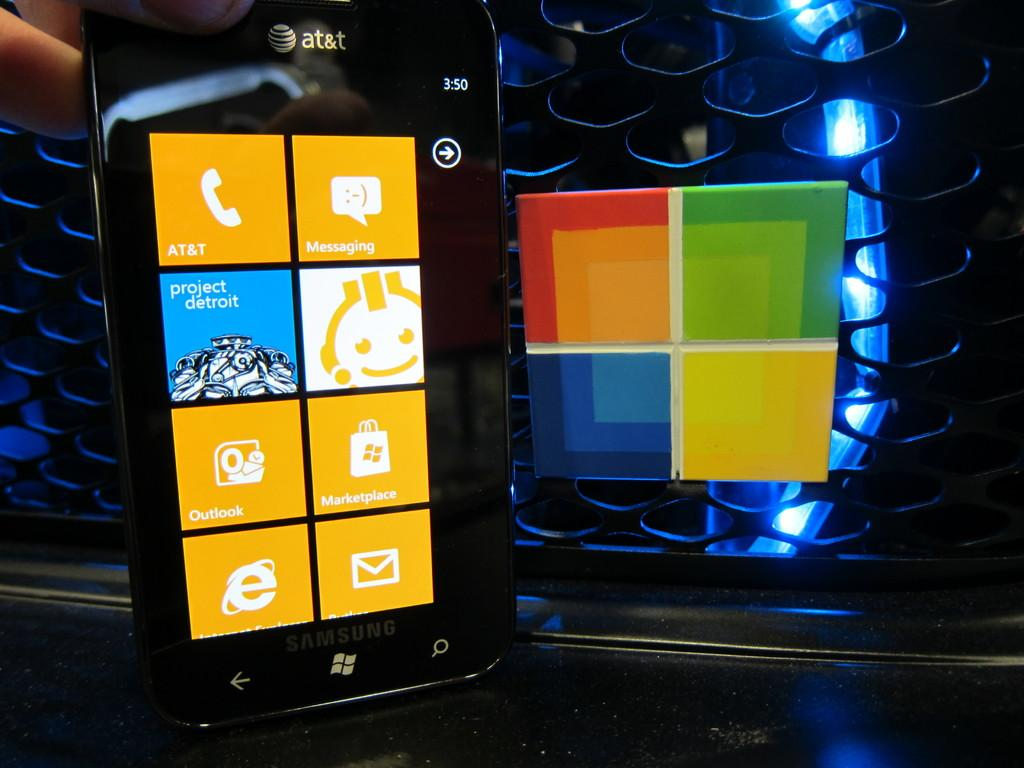<image>
Share a concise interpretation of the image provided. A smart phone with a project detroit app on it 